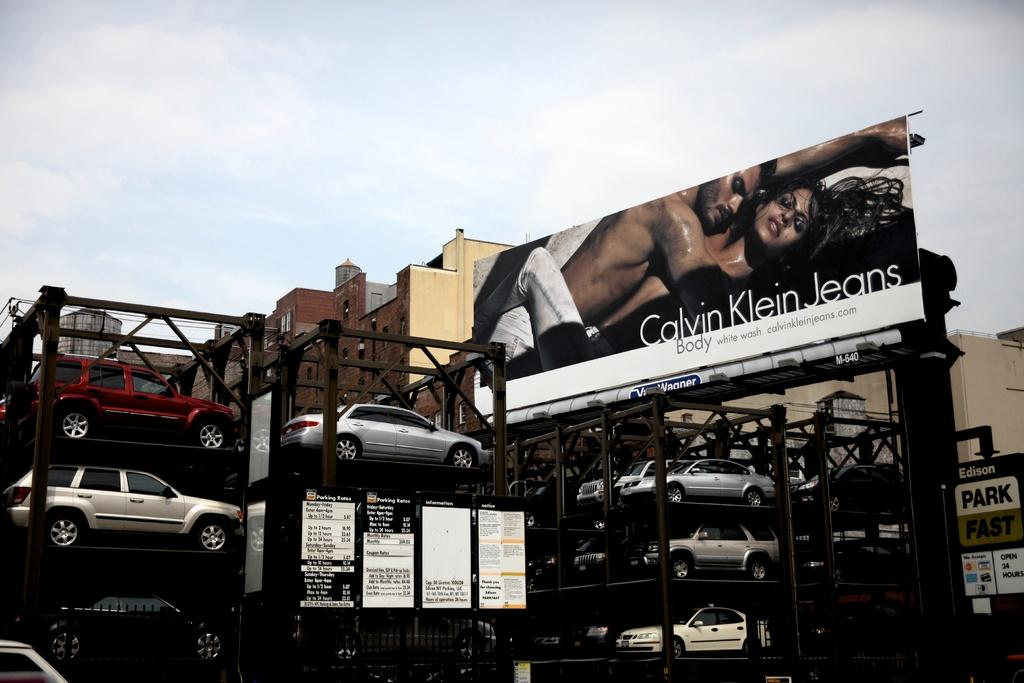What type of structure is used to store cars in the image? There are cars in auto stackers in the image. What other objects can be seen in the image? There are boards in the image. What is depicted on the hoarding in the image? There is a hoarding of two persons and words in the image. What can be seen in the background of the image? There are buildings and the sky visible in the background of the image. What type of metal is used to make the grain visible in the image? There is no mention of grain or metal in the image; it features cars in auto stackers, boards, a hoarding, buildings, and the sky. 